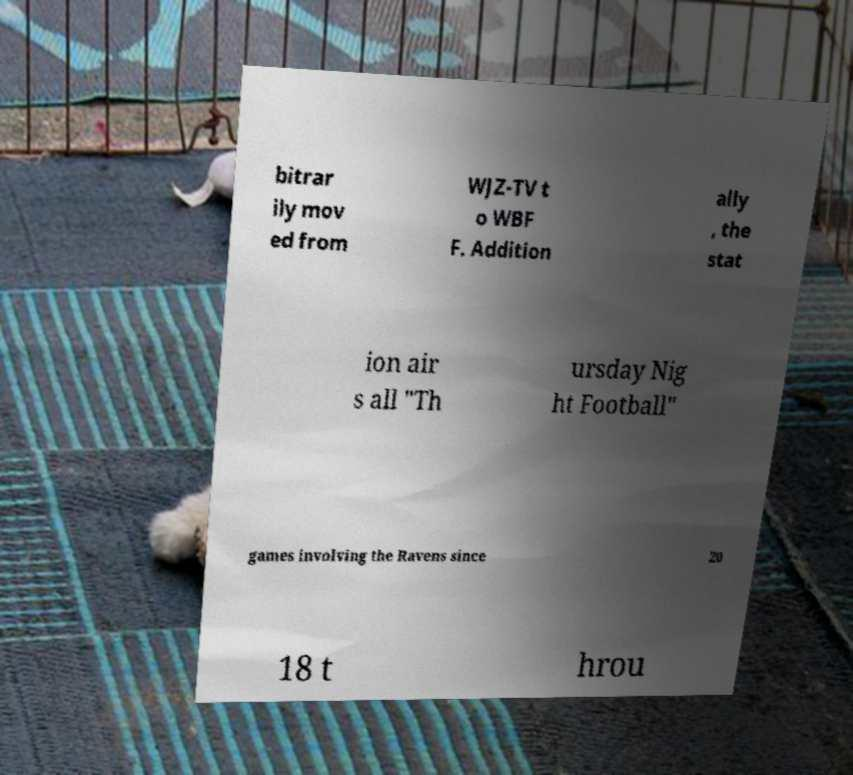What messages or text are displayed in this image? I need them in a readable, typed format. bitrar ily mov ed from WJZ-TV t o WBF F. Addition ally , the stat ion air s all "Th ursday Nig ht Football" games involving the Ravens since 20 18 t hrou 